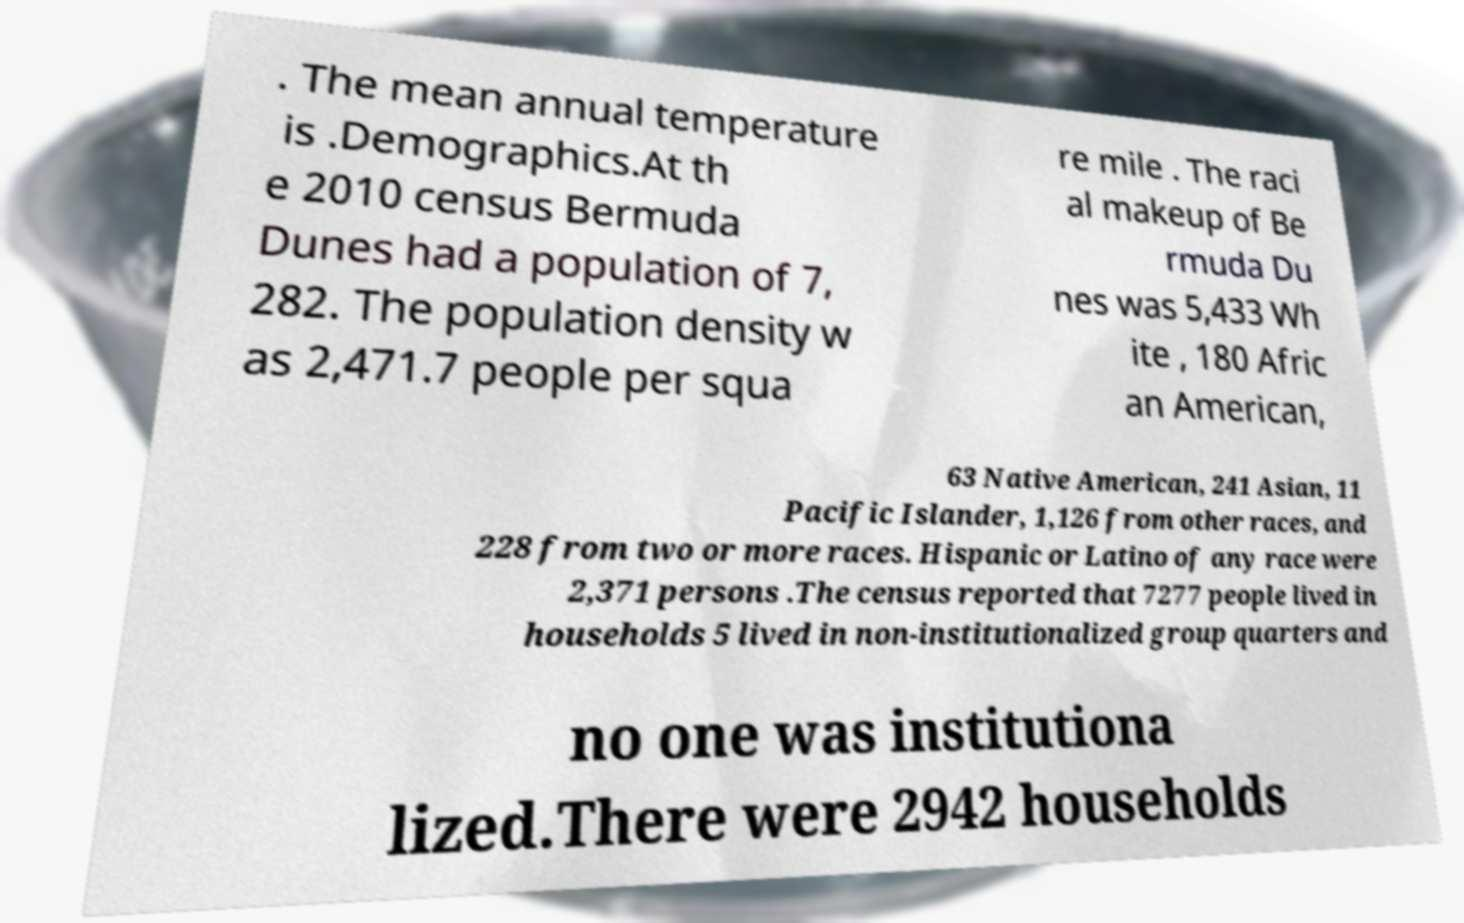For documentation purposes, I need the text within this image transcribed. Could you provide that? . The mean annual temperature is .Demographics.At th e 2010 census Bermuda Dunes had a population of 7, 282. The population density w as 2,471.7 people per squa re mile . The raci al makeup of Be rmuda Du nes was 5,433 Wh ite , 180 Afric an American, 63 Native American, 241 Asian, 11 Pacific Islander, 1,126 from other races, and 228 from two or more races. Hispanic or Latino of any race were 2,371 persons .The census reported that 7277 people lived in households 5 lived in non-institutionalized group quarters and no one was institutiona lized.There were 2942 households 